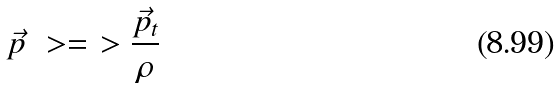Convert formula to latex. <formula><loc_0><loc_0><loc_500><loc_500>\vec { p } \ > = \ > \frac { \vec { p } _ { t } } { \rho }</formula> 